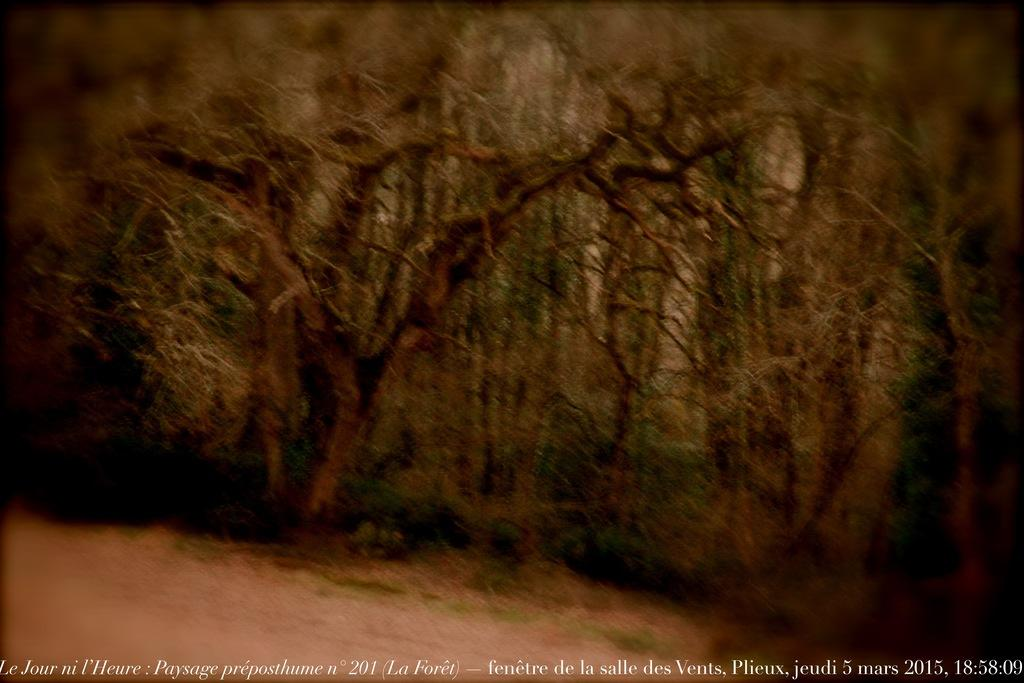What is the main subject in the center of the image? There are trees in the center of the image. What effect does the yoke have on the trees in the image? There is no yoke present in the image, so it cannot have any effect on the trees. 